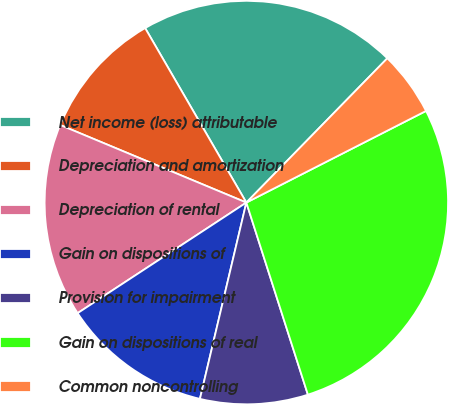Convert chart to OTSL. <chart><loc_0><loc_0><loc_500><loc_500><pie_chart><fcel>Net income (loss) attributable<fcel>Depreciation and amortization<fcel>Depreciation of rental<fcel>Gain on dispositions of<fcel>Provision for impairment<fcel>Gain on dispositions of real<fcel>Common noncontrolling<nl><fcel>20.68%<fcel>10.35%<fcel>15.52%<fcel>12.07%<fcel>8.63%<fcel>27.57%<fcel>5.18%<nl></chart> 